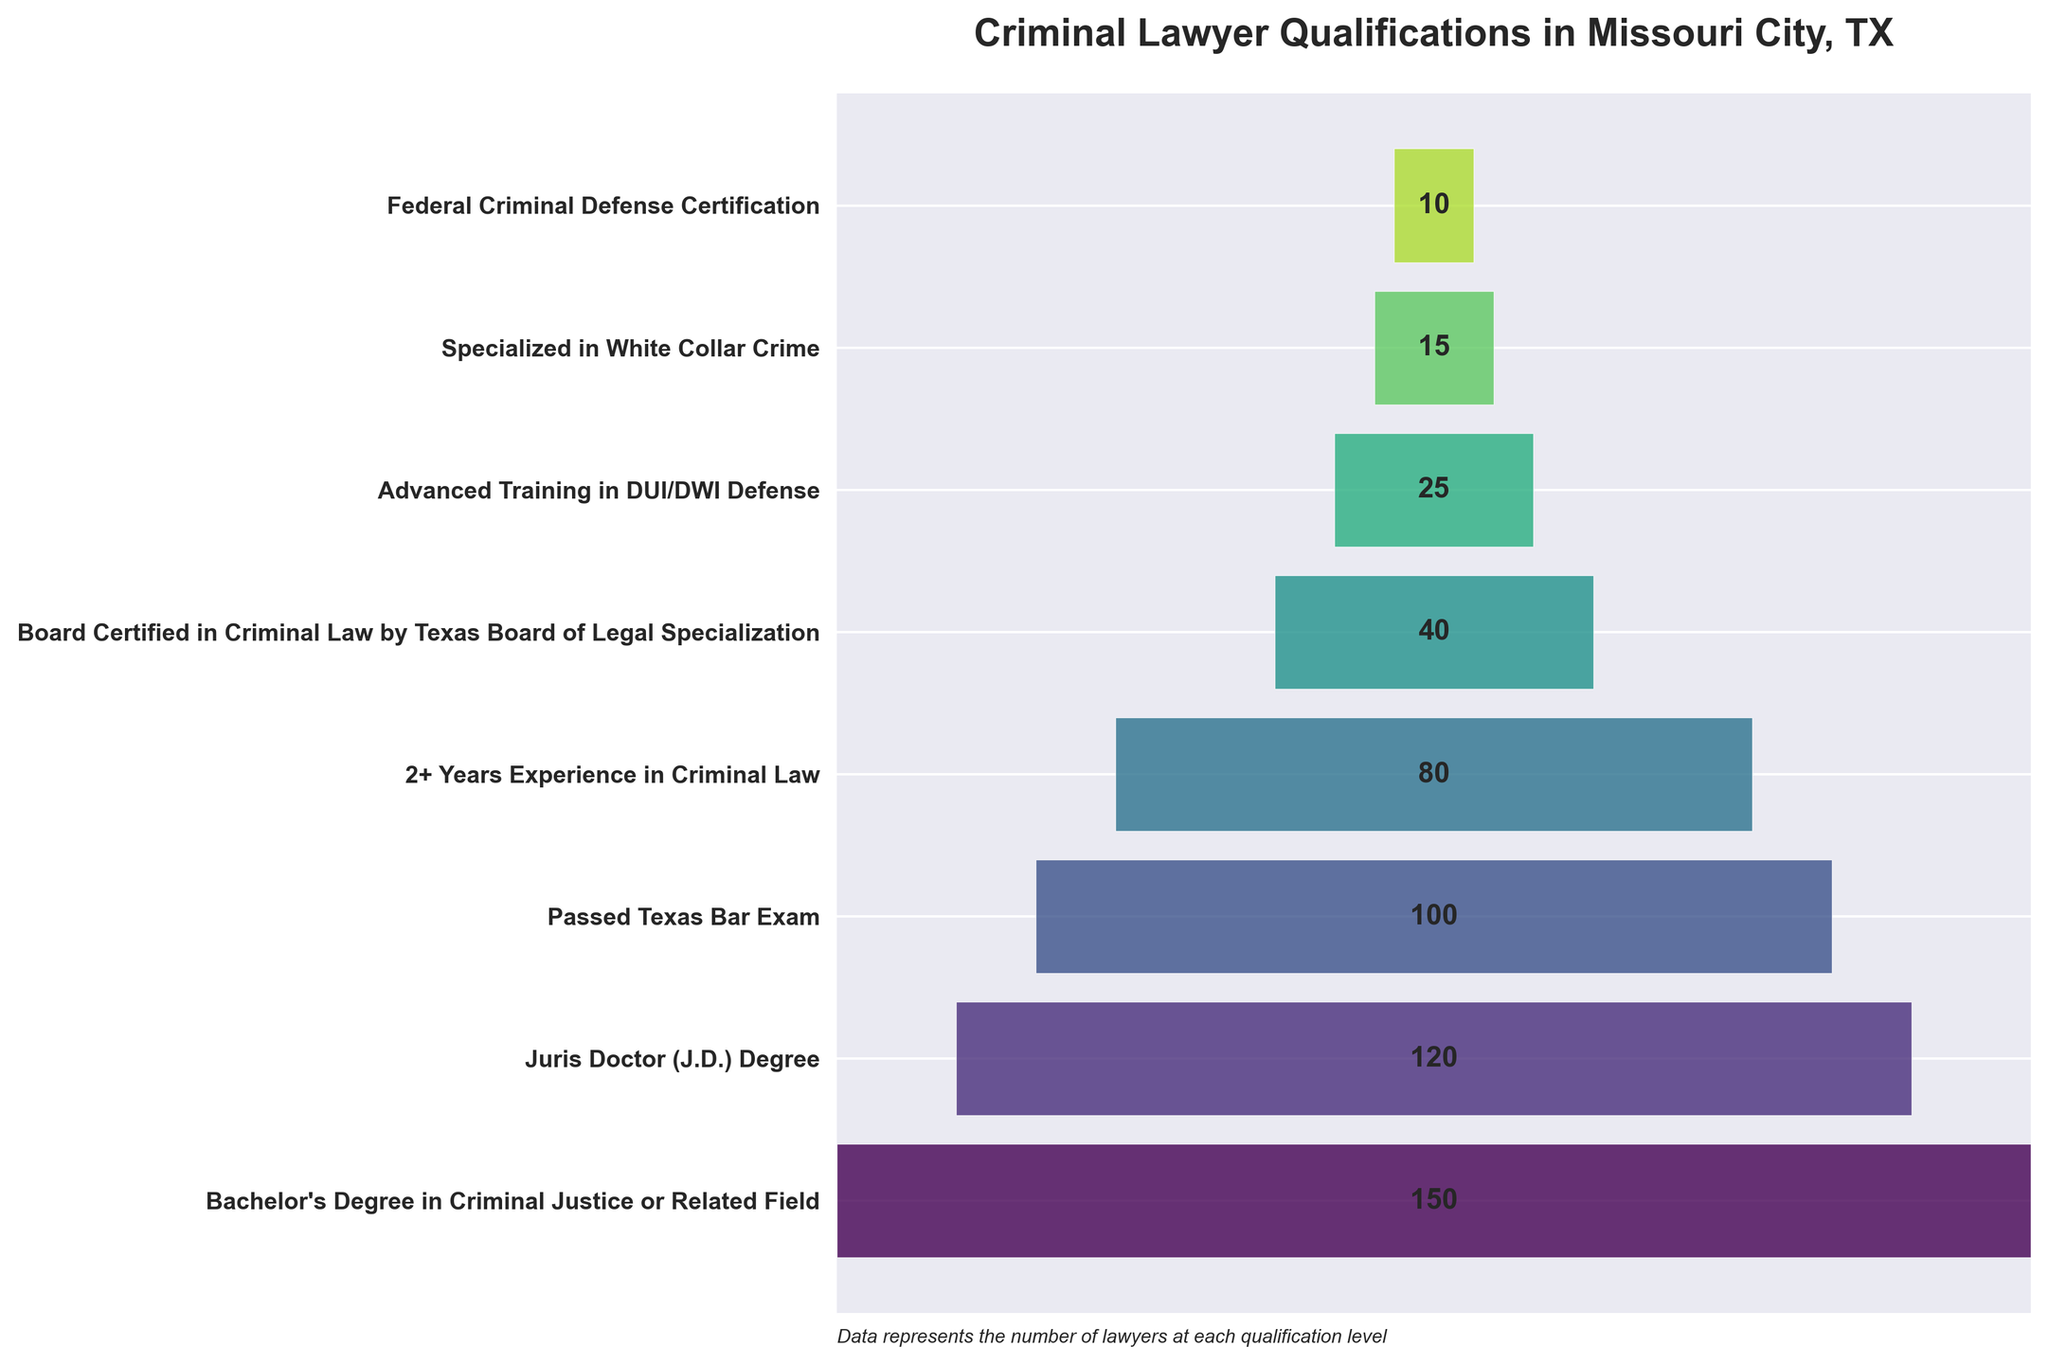What is the title of the figure? The title is usually displayed at the top of the chart and helps to understand the main subject of the chart. In this case, it summarizes the qualifications being displayed for criminal lawyers in Missouri City.
Answer: Criminal Lawyer Qualifications in Missouri City, TX How many stages are shown in the funnel chart? To find the number of stages, count the number of distinct segments or labels on the y-axis of the chart. Each represents a different qualification level.
Answer: 8 What are the stages with the highest and the lowest number of lawyers? Examine the labels on the y-axis along with their corresponding bars. The stage with the widest bar (highest value) has the most lawyers, and the stage with the narrowest bar (lowest value) has the fewest lawyers.
Answer: Highest: Bachelor's Degree in Criminal Justice or Related Field, Lowest: Federal Criminal Defense Certification How many lawyers have at least 2 years of experience in criminal law? Look at the length of the bar corresponding to the stage labeled "2+ Years Experience in Criminal Law". The value associated with this bar indicates the number of lawyers.
Answer: 80 Compare the number of lawyers who have passed the Texas Bar Exam to those who are Board Certified in Criminal Law by the Texas Board of Legal Specialization. Which stage has more lawyers, and by how much? Identify the values for both "Passed Texas Bar Exam" and "Board Certified in Criminal Law by Texas Board of Legal Specialization". Subtract the latter value from the former to find the difference and determine which is larger.
Answer: Passed Texas Bar Exam stage has more lawyers by 60 What percentage of lawyers with a Juris Doctor (J.D.) Degree have passed the Texas Bar Exam? The number of lawyers with a Juris Doctor degree is 120, and those who have passed the Texas Bar Exam are 100. Calculate the percentage by dividing the latter by the former and multiplying by 100.
Answer: 83.33% Which stage shows the most significant drop in the number of lawyers compared to its preceding stage? Calculate the difference in the number of lawyers between each successive stage. Identify the pair with the largest difference to determine where the most significant drop occurs.
Answer: Juris Doctor (J.D.) Degree to Passed Texas Bar Exam How many more lawyers have advanced training in DUI/DWI defense compared to those specialized in white-collar crime? Identify the bars labeled "Advanced Training in DUI/DWI Defense" and "Specialized in White Collar Crime". Subtract the number for white-collar crime from the DUI/DWI defense value.
Answer: 10 What's the sum of the lawyers who are either Board Certified or have Federal Criminal Defense Certification? Add the values for "Board Certified in Criminal Law by Texas Board of Legal Specialization" and "Federal Criminal Defense Certification".
Answer: 50 